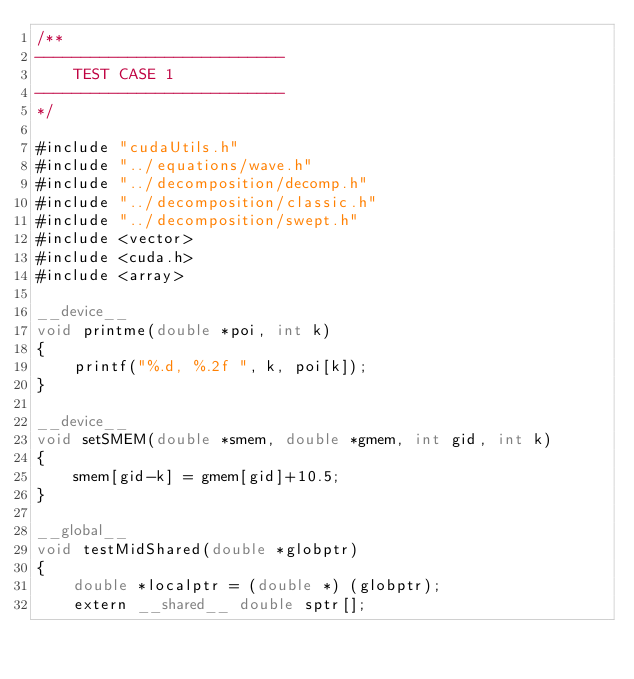<code> <loc_0><loc_0><loc_500><loc_500><_Cuda_>/**
---------------------------
    TEST CASE 1
---------------------------
*/

#include "cudaUtils.h"
#include "../equations/wave.h"
#include "../decomposition/decomp.h"
#include "../decomposition/classic.h"
#include "../decomposition/swept.h"
#include <vector>
#include <cuda.h>
#include <array>

__device__
void printme(double *poi, int k)
{
    printf("%.d, %.2f ", k, poi[k]);
}

__device__ 
void setSMEM(double *smem, double *gmem, int gid, int k)
{
    smem[gid-k] = gmem[gid]+10.5;
}

__global__
void testMidShared(double *globptr)
{
    double *localptr = (double *) (globptr); 
    extern __shared__ double sptr[];
    </code> 